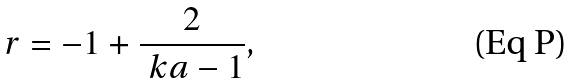Convert formula to latex. <formula><loc_0><loc_0><loc_500><loc_500>r = - 1 + \frac { 2 } { \ k a - 1 } ,</formula> 